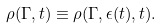<formula> <loc_0><loc_0><loc_500><loc_500>\rho ( \Gamma , t ) \equiv \rho ( \Gamma , \epsilon ( t ) , t ) .</formula> 